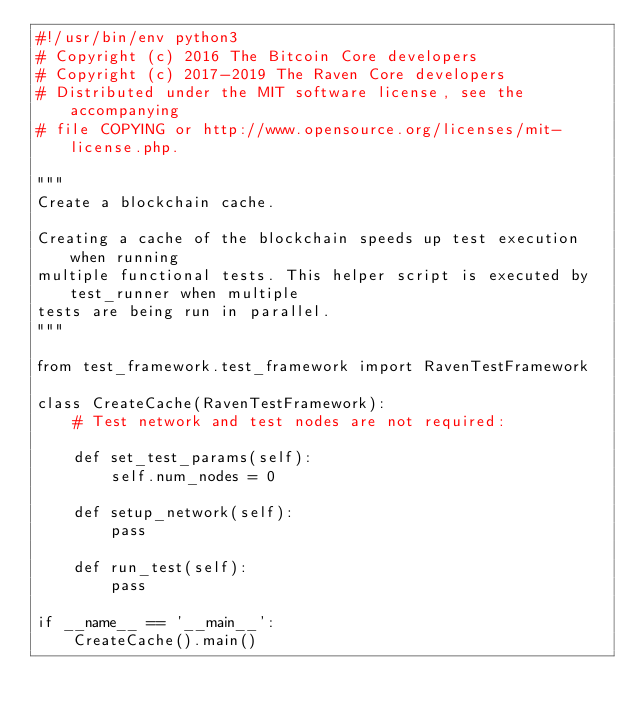Convert code to text. <code><loc_0><loc_0><loc_500><loc_500><_Python_>#!/usr/bin/env python3
# Copyright (c) 2016 The Bitcoin Core developers
# Copyright (c) 2017-2019 The Raven Core developers
# Distributed under the MIT software license, see the accompanying
# file COPYING or http://www.opensource.org/licenses/mit-license.php.

"""
Create a blockchain cache.

Creating a cache of the blockchain speeds up test execution when running
multiple functional tests. This helper script is executed by test_runner when multiple
tests are being run in parallel.
"""

from test_framework.test_framework import RavenTestFramework

class CreateCache(RavenTestFramework):
    # Test network and test nodes are not required:

    def set_test_params(self):
        self.num_nodes = 0

    def setup_network(self):
        pass

    def run_test(self):
        pass

if __name__ == '__main__':
    CreateCache().main()
</code> 